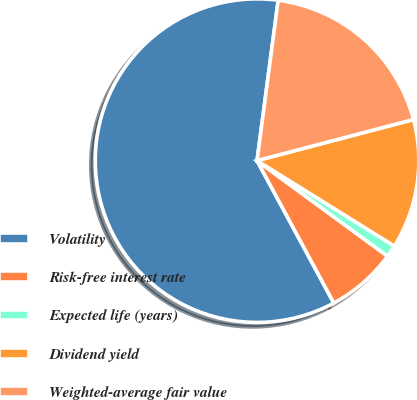Convert chart to OTSL. <chart><loc_0><loc_0><loc_500><loc_500><pie_chart><fcel>Volatility<fcel>Risk-free interest rate<fcel>Expected life (years)<fcel>Dividend yield<fcel>Weighted-average fair value<nl><fcel>59.95%<fcel>7.07%<fcel>1.2%<fcel>12.95%<fcel>18.82%<nl></chart> 